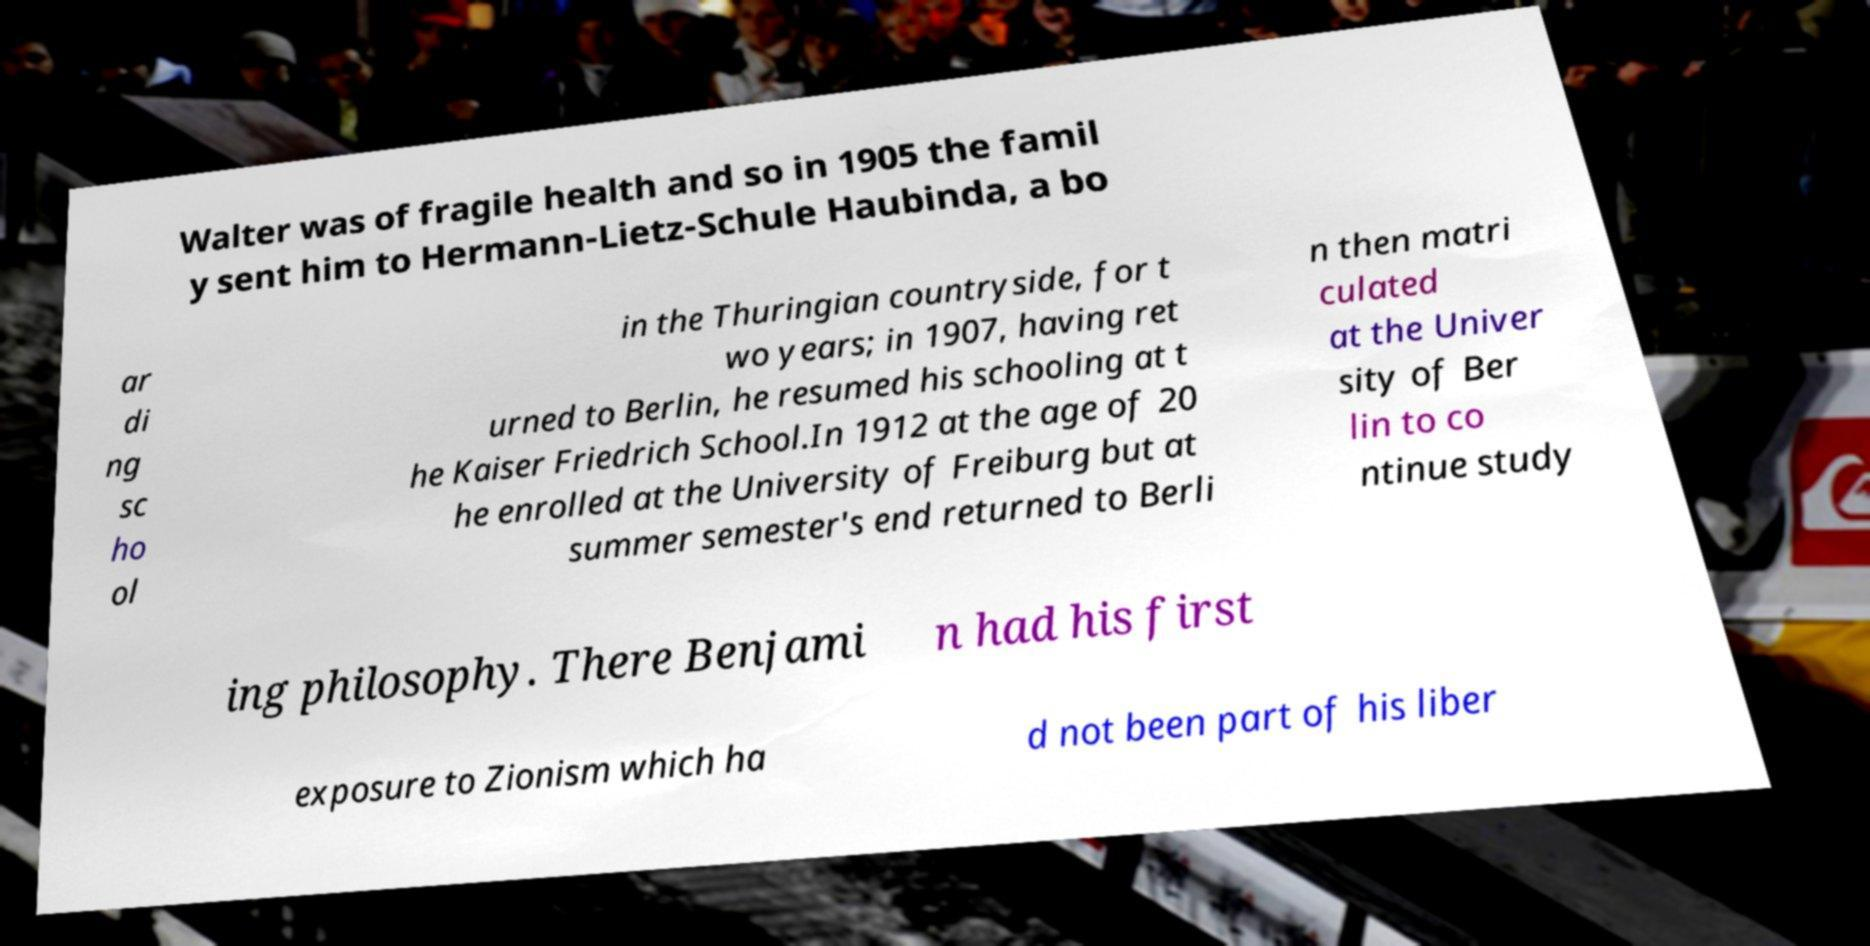Please identify and transcribe the text found in this image. Walter was of fragile health and so in 1905 the famil y sent him to Hermann-Lietz-Schule Haubinda, a bo ar di ng sc ho ol in the Thuringian countryside, for t wo years; in 1907, having ret urned to Berlin, he resumed his schooling at t he Kaiser Friedrich School.In 1912 at the age of 20 he enrolled at the University of Freiburg but at summer semester's end returned to Berli n then matri culated at the Univer sity of Ber lin to co ntinue study ing philosophy. There Benjami n had his first exposure to Zionism which ha d not been part of his liber 